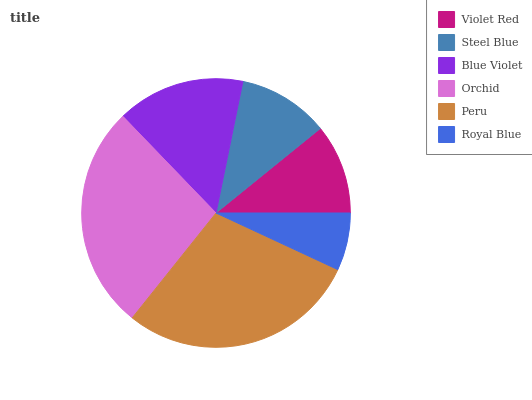Is Royal Blue the minimum?
Answer yes or no. Yes. Is Peru the maximum?
Answer yes or no. Yes. Is Steel Blue the minimum?
Answer yes or no. No. Is Steel Blue the maximum?
Answer yes or no. No. Is Steel Blue greater than Violet Red?
Answer yes or no. Yes. Is Violet Red less than Steel Blue?
Answer yes or no. Yes. Is Violet Red greater than Steel Blue?
Answer yes or no. No. Is Steel Blue less than Violet Red?
Answer yes or no. No. Is Blue Violet the high median?
Answer yes or no. Yes. Is Steel Blue the low median?
Answer yes or no. Yes. Is Steel Blue the high median?
Answer yes or no. No. Is Violet Red the low median?
Answer yes or no. No. 